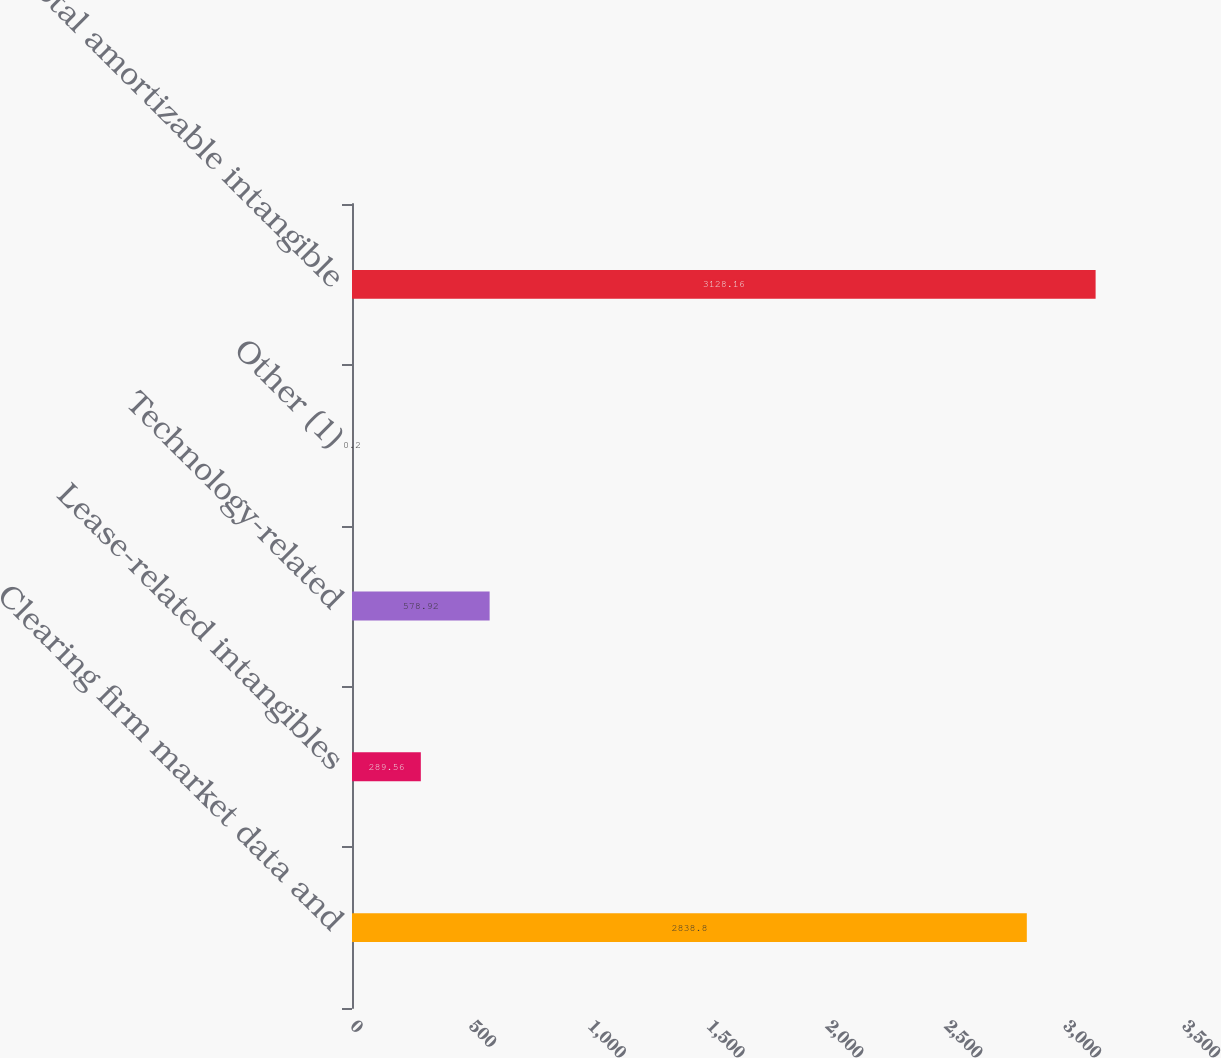Convert chart to OTSL. <chart><loc_0><loc_0><loc_500><loc_500><bar_chart><fcel>Clearing firm market data and<fcel>Lease-related intangibles<fcel>Technology-related<fcel>Other (1)<fcel>Total amortizable intangible<nl><fcel>2838.8<fcel>289.56<fcel>578.92<fcel>0.2<fcel>3128.16<nl></chart> 